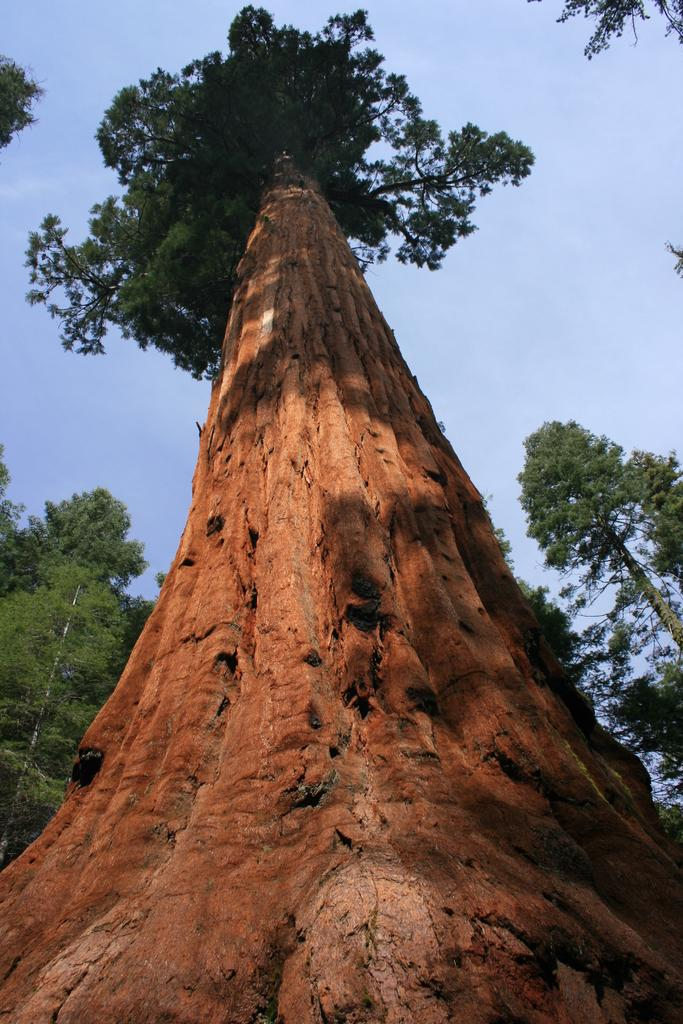What type of vegetation can be seen in the image? There are trees in the image. What is visible at the top of the image? The sky is visible at the top of the image. How many ears of corn can be seen in the image? There is no corn present in the image. What type of coach is visible in the image? There is no coach present in the image. 